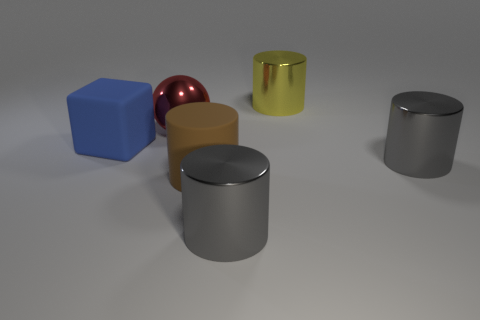Is there anything else that has the same shape as the big blue object?
Your response must be concise. No. Does the big cylinder on the right side of the yellow metallic object have the same color as the metallic cylinder behind the blue object?
Ensure brevity in your answer.  No. Does the gray object in front of the big brown thing have the same material as the large gray thing that is behind the large rubber cylinder?
Keep it short and to the point. Yes. How many balls have the same size as the brown thing?
Provide a succinct answer. 1. Are there fewer big matte cylinders than tiny gray metal cylinders?
Offer a very short reply. No. There is a large yellow thing that is behind the gray metallic thing left of the yellow object; what shape is it?
Offer a very short reply. Cylinder. There is a blue object that is the same size as the yellow shiny cylinder; what shape is it?
Your answer should be very brief. Cube. Is there a tiny cyan object that has the same shape as the big yellow metallic thing?
Your response must be concise. No. What is the big yellow object made of?
Give a very brief answer. Metal. There is a blue matte block; are there any large blue rubber objects behind it?
Give a very brief answer. No. 